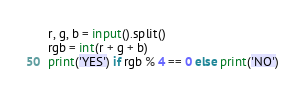Convert code to text. <code><loc_0><loc_0><loc_500><loc_500><_Python_>r, g, b = input().split()
rgb = int(r + g + b)
print('YES') if rgb % 4 == 0 else print('NO')
</code> 